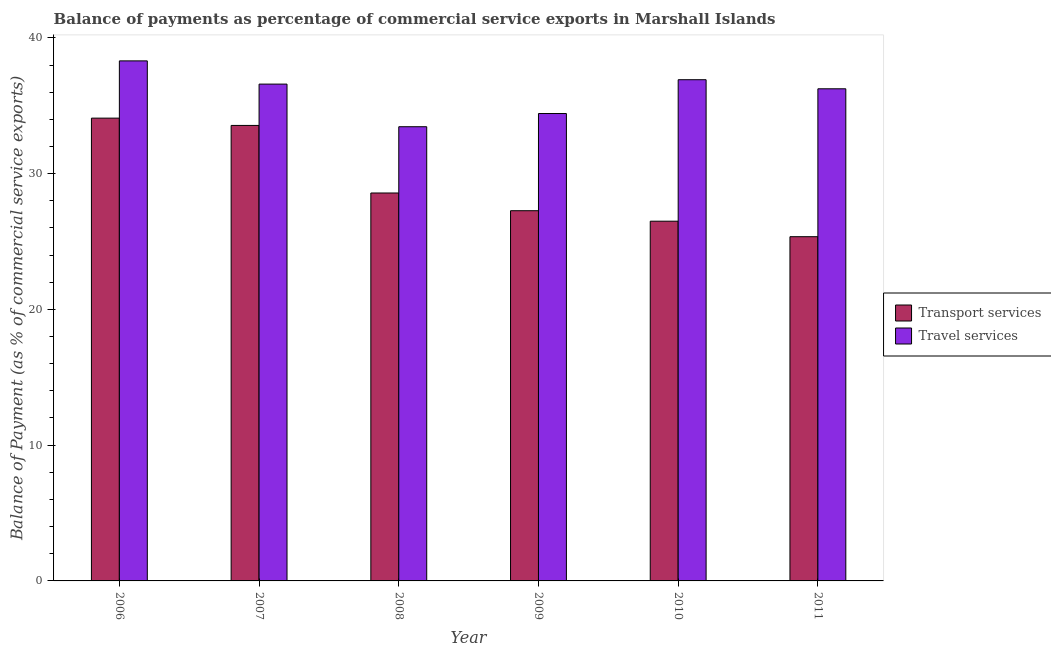How many different coloured bars are there?
Your response must be concise. 2. How many groups of bars are there?
Offer a very short reply. 6. Are the number of bars per tick equal to the number of legend labels?
Your answer should be compact. Yes. Are the number of bars on each tick of the X-axis equal?
Ensure brevity in your answer.  Yes. How many bars are there on the 5th tick from the left?
Provide a succinct answer. 2. How many bars are there on the 1st tick from the right?
Keep it short and to the point. 2. What is the balance of payments of transport services in 2011?
Your response must be concise. 25.35. Across all years, what is the maximum balance of payments of transport services?
Offer a terse response. 34.09. Across all years, what is the minimum balance of payments of travel services?
Provide a succinct answer. 33.45. What is the total balance of payments of transport services in the graph?
Give a very brief answer. 175.33. What is the difference between the balance of payments of travel services in 2007 and that in 2010?
Offer a terse response. -0.32. What is the difference between the balance of payments of transport services in 2006 and the balance of payments of travel services in 2007?
Keep it short and to the point. 0.54. What is the average balance of payments of transport services per year?
Offer a very short reply. 29.22. In how many years, is the balance of payments of transport services greater than 4 %?
Keep it short and to the point. 6. What is the ratio of the balance of payments of travel services in 2007 to that in 2010?
Your answer should be very brief. 0.99. What is the difference between the highest and the second highest balance of payments of travel services?
Offer a very short reply. 1.39. What is the difference between the highest and the lowest balance of payments of transport services?
Ensure brevity in your answer.  8.73. What does the 1st bar from the left in 2010 represents?
Ensure brevity in your answer.  Transport services. What does the 1st bar from the right in 2009 represents?
Your answer should be compact. Travel services. How many bars are there?
Give a very brief answer. 12. Are all the bars in the graph horizontal?
Ensure brevity in your answer.  No. How many years are there in the graph?
Provide a short and direct response. 6. Does the graph contain any zero values?
Ensure brevity in your answer.  No. What is the title of the graph?
Provide a short and direct response. Balance of payments as percentage of commercial service exports in Marshall Islands. Does "GDP per capita" appear as one of the legend labels in the graph?
Your answer should be compact. No. What is the label or title of the X-axis?
Provide a succinct answer. Year. What is the label or title of the Y-axis?
Keep it short and to the point. Balance of Payment (as % of commercial service exports). What is the Balance of Payment (as % of commercial service exports) in Transport services in 2006?
Keep it short and to the point. 34.09. What is the Balance of Payment (as % of commercial service exports) of Travel services in 2006?
Keep it short and to the point. 38.3. What is the Balance of Payment (as % of commercial service exports) of Transport services in 2007?
Your answer should be compact. 33.55. What is the Balance of Payment (as % of commercial service exports) in Travel services in 2007?
Give a very brief answer. 36.59. What is the Balance of Payment (as % of commercial service exports) in Transport services in 2008?
Keep it short and to the point. 28.57. What is the Balance of Payment (as % of commercial service exports) in Travel services in 2008?
Give a very brief answer. 33.45. What is the Balance of Payment (as % of commercial service exports) of Transport services in 2009?
Your answer should be compact. 27.27. What is the Balance of Payment (as % of commercial service exports) of Travel services in 2009?
Make the answer very short. 34.43. What is the Balance of Payment (as % of commercial service exports) of Transport services in 2010?
Make the answer very short. 26.5. What is the Balance of Payment (as % of commercial service exports) of Travel services in 2010?
Your answer should be very brief. 36.92. What is the Balance of Payment (as % of commercial service exports) of Transport services in 2011?
Your answer should be compact. 25.35. What is the Balance of Payment (as % of commercial service exports) of Travel services in 2011?
Ensure brevity in your answer.  36.25. Across all years, what is the maximum Balance of Payment (as % of commercial service exports) of Transport services?
Make the answer very short. 34.09. Across all years, what is the maximum Balance of Payment (as % of commercial service exports) of Travel services?
Provide a short and direct response. 38.3. Across all years, what is the minimum Balance of Payment (as % of commercial service exports) in Transport services?
Offer a very short reply. 25.35. Across all years, what is the minimum Balance of Payment (as % of commercial service exports) of Travel services?
Ensure brevity in your answer.  33.45. What is the total Balance of Payment (as % of commercial service exports) of Transport services in the graph?
Give a very brief answer. 175.33. What is the total Balance of Payment (as % of commercial service exports) in Travel services in the graph?
Keep it short and to the point. 215.94. What is the difference between the Balance of Payment (as % of commercial service exports) of Transport services in 2006 and that in 2007?
Ensure brevity in your answer.  0.54. What is the difference between the Balance of Payment (as % of commercial service exports) in Travel services in 2006 and that in 2007?
Give a very brief answer. 1.71. What is the difference between the Balance of Payment (as % of commercial service exports) of Transport services in 2006 and that in 2008?
Offer a very short reply. 5.51. What is the difference between the Balance of Payment (as % of commercial service exports) of Travel services in 2006 and that in 2008?
Keep it short and to the point. 4.85. What is the difference between the Balance of Payment (as % of commercial service exports) of Transport services in 2006 and that in 2009?
Give a very brief answer. 6.82. What is the difference between the Balance of Payment (as % of commercial service exports) in Travel services in 2006 and that in 2009?
Your answer should be very brief. 3.88. What is the difference between the Balance of Payment (as % of commercial service exports) of Transport services in 2006 and that in 2010?
Keep it short and to the point. 7.59. What is the difference between the Balance of Payment (as % of commercial service exports) in Travel services in 2006 and that in 2010?
Your response must be concise. 1.39. What is the difference between the Balance of Payment (as % of commercial service exports) in Transport services in 2006 and that in 2011?
Offer a very short reply. 8.73. What is the difference between the Balance of Payment (as % of commercial service exports) in Travel services in 2006 and that in 2011?
Your response must be concise. 2.06. What is the difference between the Balance of Payment (as % of commercial service exports) of Transport services in 2007 and that in 2008?
Give a very brief answer. 4.98. What is the difference between the Balance of Payment (as % of commercial service exports) of Travel services in 2007 and that in 2008?
Your answer should be compact. 3.14. What is the difference between the Balance of Payment (as % of commercial service exports) in Transport services in 2007 and that in 2009?
Give a very brief answer. 6.28. What is the difference between the Balance of Payment (as % of commercial service exports) in Travel services in 2007 and that in 2009?
Give a very brief answer. 2.17. What is the difference between the Balance of Payment (as % of commercial service exports) of Transport services in 2007 and that in 2010?
Your answer should be compact. 7.05. What is the difference between the Balance of Payment (as % of commercial service exports) in Travel services in 2007 and that in 2010?
Your answer should be very brief. -0.32. What is the difference between the Balance of Payment (as % of commercial service exports) of Transport services in 2007 and that in 2011?
Provide a short and direct response. 8.2. What is the difference between the Balance of Payment (as % of commercial service exports) of Travel services in 2007 and that in 2011?
Provide a short and direct response. 0.35. What is the difference between the Balance of Payment (as % of commercial service exports) of Transport services in 2008 and that in 2009?
Offer a terse response. 1.31. What is the difference between the Balance of Payment (as % of commercial service exports) in Travel services in 2008 and that in 2009?
Provide a succinct answer. -0.97. What is the difference between the Balance of Payment (as % of commercial service exports) of Transport services in 2008 and that in 2010?
Offer a terse response. 2.08. What is the difference between the Balance of Payment (as % of commercial service exports) in Travel services in 2008 and that in 2010?
Keep it short and to the point. -3.46. What is the difference between the Balance of Payment (as % of commercial service exports) in Transport services in 2008 and that in 2011?
Keep it short and to the point. 3.22. What is the difference between the Balance of Payment (as % of commercial service exports) in Travel services in 2008 and that in 2011?
Provide a short and direct response. -2.79. What is the difference between the Balance of Payment (as % of commercial service exports) in Transport services in 2009 and that in 2010?
Provide a short and direct response. 0.77. What is the difference between the Balance of Payment (as % of commercial service exports) in Travel services in 2009 and that in 2010?
Offer a terse response. -2.49. What is the difference between the Balance of Payment (as % of commercial service exports) in Transport services in 2009 and that in 2011?
Provide a short and direct response. 1.91. What is the difference between the Balance of Payment (as % of commercial service exports) of Travel services in 2009 and that in 2011?
Make the answer very short. -1.82. What is the difference between the Balance of Payment (as % of commercial service exports) in Transport services in 2010 and that in 2011?
Give a very brief answer. 1.14. What is the difference between the Balance of Payment (as % of commercial service exports) in Travel services in 2010 and that in 2011?
Offer a very short reply. 0.67. What is the difference between the Balance of Payment (as % of commercial service exports) of Transport services in 2006 and the Balance of Payment (as % of commercial service exports) of Travel services in 2007?
Your answer should be compact. -2.51. What is the difference between the Balance of Payment (as % of commercial service exports) in Transport services in 2006 and the Balance of Payment (as % of commercial service exports) in Travel services in 2008?
Provide a succinct answer. 0.63. What is the difference between the Balance of Payment (as % of commercial service exports) in Transport services in 2006 and the Balance of Payment (as % of commercial service exports) in Travel services in 2009?
Give a very brief answer. -0.34. What is the difference between the Balance of Payment (as % of commercial service exports) of Transport services in 2006 and the Balance of Payment (as % of commercial service exports) of Travel services in 2010?
Provide a short and direct response. -2.83. What is the difference between the Balance of Payment (as % of commercial service exports) in Transport services in 2006 and the Balance of Payment (as % of commercial service exports) in Travel services in 2011?
Offer a terse response. -2.16. What is the difference between the Balance of Payment (as % of commercial service exports) in Transport services in 2007 and the Balance of Payment (as % of commercial service exports) in Travel services in 2008?
Offer a very short reply. 0.1. What is the difference between the Balance of Payment (as % of commercial service exports) of Transport services in 2007 and the Balance of Payment (as % of commercial service exports) of Travel services in 2009?
Offer a terse response. -0.88. What is the difference between the Balance of Payment (as % of commercial service exports) of Transport services in 2007 and the Balance of Payment (as % of commercial service exports) of Travel services in 2010?
Provide a short and direct response. -3.37. What is the difference between the Balance of Payment (as % of commercial service exports) of Transport services in 2007 and the Balance of Payment (as % of commercial service exports) of Travel services in 2011?
Provide a short and direct response. -2.7. What is the difference between the Balance of Payment (as % of commercial service exports) of Transport services in 2008 and the Balance of Payment (as % of commercial service exports) of Travel services in 2009?
Provide a short and direct response. -5.85. What is the difference between the Balance of Payment (as % of commercial service exports) of Transport services in 2008 and the Balance of Payment (as % of commercial service exports) of Travel services in 2010?
Ensure brevity in your answer.  -8.34. What is the difference between the Balance of Payment (as % of commercial service exports) in Transport services in 2008 and the Balance of Payment (as % of commercial service exports) in Travel services in 2011?
Offer a terse response. -7.67. What is the difference between the Balance of Payment (as % of commercial service exports) in Transport services in 2009 and the Balance of Payment (as % of commercial service exports) in Travel services in 2010?
Your answer should be very brief. -9.65. What is the difference between the Balance of Payment (as % of commercial service exports) in Transport services in 2009 and the Balance of Payment (as % of commercial service exports) in Travel services in 2011?
Provide a short and direct response. -8.98. What is the difference between the Balance of Payment (as % of commercial service exports) of Transport services in 2010 and the Balance of Payment (as % of commercial service exports) of Travel services in 2011?
Offer a very short reply. -9.75. What is the average Balance of Payment (as % of commercial service exports) in Transport services per year?
Ensure brevity in your answer.  29.22. What is the average Balance of Payment (as % of commercial service exports) in Travel services per year?
Give a very brief answer. 35.99. In the year 2006, what is the difference between the Balance of Payment (as % of commercial service exports) in Transport services and Balance of Payment (as % of commercial service exports) in Travel services?
Offer a very short reply. -4.22. In the year 2007, what is the difference between the Balance of Payment (as % of commercial service exports) in Transport services and Balance of Payment (as % of commercial service exports) in Travel services?
Offer a very short reply. -3.04. In the year 2008, what is the difference between the Balance of Payment (as % of commercial service exports) in Transport services and Balance of Payment (as % of commercial service exports) in Travel services?
Your response must be concise. -4.88. In the year 2009, what is the difference between the Balance of Payment (as % of commercial service exports) of Transport services and Balance of Payment (as % of commercial service exports) of Travel services?
Your answer should be very brief. -7.16. In the year 2010, what is the difference between the Balance of Payment (as % of commercial service exports) in Transport services and Balance of Payment (as % of commercial service exports) in Travel services?
Offer a very short reply. -10.42. In the year 2011, what is the difference between the Balance of Payment (as % of commercial service exports) of Transport services and Balance of Payment (as % of commercial service exports) of Travel services?
Give a very brief answer. -10.89. What is the ratio of the Balance of Payment (as % of commercial service exports) in Transport services in 2006 to that in 2007?
Make the answer very short. 1.02. What is the ratio of the Balance of Payment (as % of commercial service exports) of Travel services in 2006 to that in 2007?
Give a very brief answer. 1.05. What is the ratio of the Balance of Payment (as % of commercial service exports) in Transport services in 2006 to that in 2008?
Give a very brief answer. 1.19. What is the ratio of the Balance of Payment (as % of commercial service exports) in Travel services in 2006 to that in 2008?
Keep it short and to the point. 1.15. What is the ratio of the Balance of Payment (as % of commercial service exports) in Transport services in 2006 to that in 2009?
Keep it short and to the point. 1.25. What is the ratio of the Balance of Payment (as % of commercial service exports) in Travel services in 2006 to that in 2009?
Ensure brevity in your answer.  1.11. What is the ratio of the Balance of Payment (as % of commercial service exports) of Transport services in 2006 to that in 2010?
Your answer should be compact. 1.29. What is the ratio of the Balance of Payment (as % of commercial service exports) of Travel services in 2006 to that in 2010?
Provide a succinct answer. 1.04. What is the ratio of the Balance of Payment (as % of commercial service exports) in Transport services in 2006 to that in 2011?
Make the answer very short. 1.34. What is the ratio of the Balance of Payment (as % of commercial service exports) in Travel services in 2006 to that in 2011?
Provide a short and direct response. 1.06. What is the ratio of the Balance of Payment (as % of commercial service exports) in Transport services in 2007 to that in 2008?
Your answer should be very brief. 1.17. What is the ratio of the Balance of Payment (as % of commercial service exports) in Travel services in 2007 to that in 2008?
Ensure brevity in your answer.  1.09. What is the ratio of the Balance of Payment (as % of commercial service exports) in Transport services in 2007 to that in 2009?
Keep it short and to the point. 1.23. What is the ratio of the Balance of Payment (as % of commercial service exports) of Travel services in 2007 to that in 2009?
Your response must be concise. 1.06. What is the ratio of the Balance of Payment (as % of commercial service exports) in Transport services in 2007 to that in 2010?
Offer a terse response. 1.27. What is the ratio of the Balance of Payment (as % of commercial service exports) in Travel services in 2007 to that in 2010?
Offer a very short reply. 0.99. What is the ratio of the Balance of Payment (as % of commercial service exports) of Transport services in 2007 to that in 2011?
Offer a very short reply. 1.32. What is the ratio of the Balance of Payment (as % of commercial service exports) in Travel services in 2007 to that in 2011?
Your response must be concise. 1.01. What is the ratio of the Balance of Payment (as % of commercial service exports) of Transport services in 2008 to that in 2009?
Provide a short and direct response. 1.05. What is the ratio of the Balance of Payment (as % of commercial service exports) in Travel services in 2008 to that in 2009?
Ensure brevity in your answer.  0.97. What is the ratio of the Balance of Payment (as % of commercial service exports) in Transport services in 2008 to that in 2010?
Your answer should be compact. 1.08. What is the ratio of the Balance of Payment (as % of commercial service exports) in Travel services in 2008 to that in 2010?
Make the answer very short. 0.91. What is the ratio of the Balance of Payment (as % of commercial service exports) in Transport services in 2008 to that in 2011?
Keep it short and to the point. 1.13. What is the ratio of the Balance of Payment (as % of commercial service exports) in Travel services in 2008 to that in 2011?
Your response must be concise. 0.92. What is the ratio of the Balance of Payment (as % of commercial service exports) of Transport services in 2009 to that in 2010?
Offer a very short reply. 1.03. What is the ratio of the Balance of Payment (as % of commercial service exports) of Travel services in 2009 to that in 2010?
Your answer should be very brief. 0.93. What is the ratio of the Balance of Payment (as % of commercial service exports) in Transport services in 2009 to that in 2011?
Keep it short and to the point. 1.08. What is the ratio of the Balance of Payment (as % of commercial service exports) of Travel services in 2009 to that in 2011?
Make the answer very short. 0.95. What is the ratio of the Balance of Payment (as % of commercial service exports) of Transport services in 2010 to that in 2011?
Provide a short and direct response. 1.04. What is the ratio of the Balance of Payment (as % of commercial service exports) of Travel services in 2010 to that in 2011?
Make the answer very short. 1.02. What is the difference between the highest and the second highest Balance of Payment (as % of commercial service exports) in Transport services?
Provide a short and direct response. 0.54. What is the difference between the highest and the second highest Balance of Payment (as % of commercial service exports) in Travel services?
Provide a succinct answer. 1.39. What is the difference between the highest and the lowest Balance of Payment (as % of commercial service exports) of Transport services?
Offer a terse response. 8.73. What is the difference between the highest and the lowest Balance of Payment (as % of commercial service exports) in Travel services?
Ensure brevity in your answer.  4.85. 